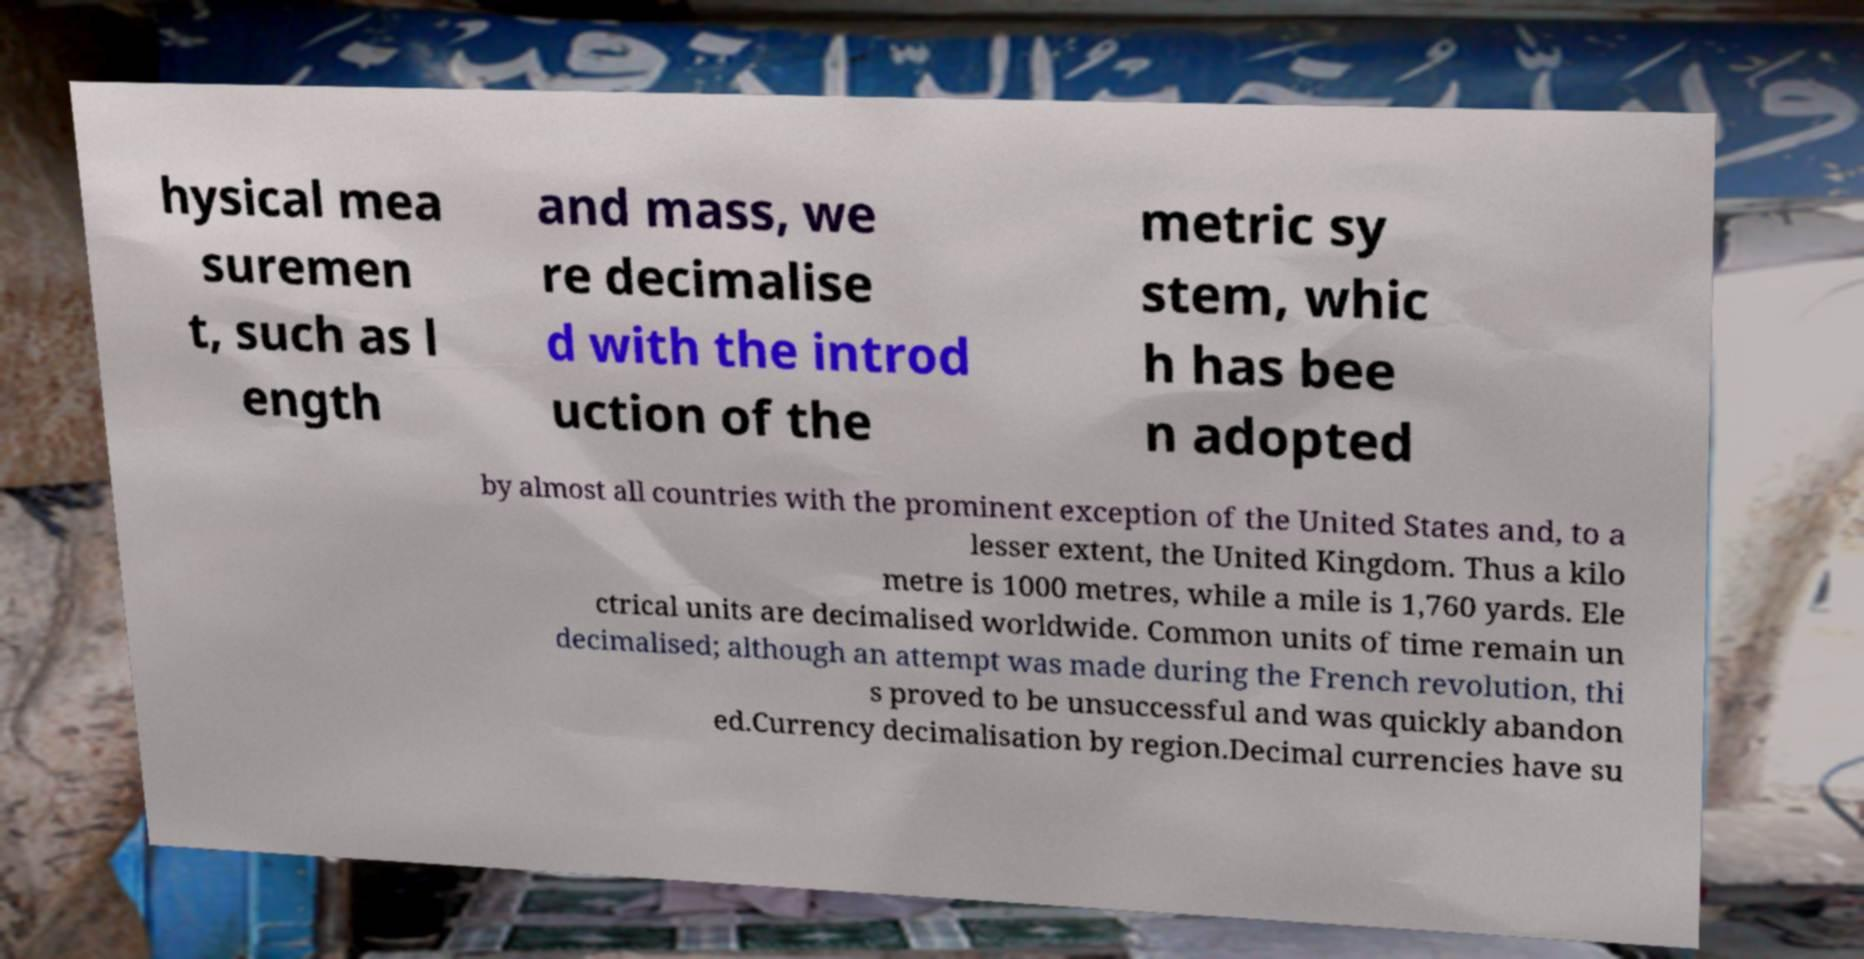What messages or text are displayed in this image? I need them in a readable, typed format. hysical mea suremen t, such as l ength and mass, we re decimalise d with the introd uction of the metric sy stem, whic h has bee n adopted by almost all countries with the prominent exception of the United States and, to a lesser extent, the United Kingdom. Thus a kilo metre is 1000 metres, while a mile is 1,760 yards. Ele ctrical units are decimalised worldwide. Common units of time remain un decimalised; although an attempt was made during the French revolution, thi s proved to be unsuccessful and was quickly abandon ed.Currency decimalisation by region.Decimal currencies have su 